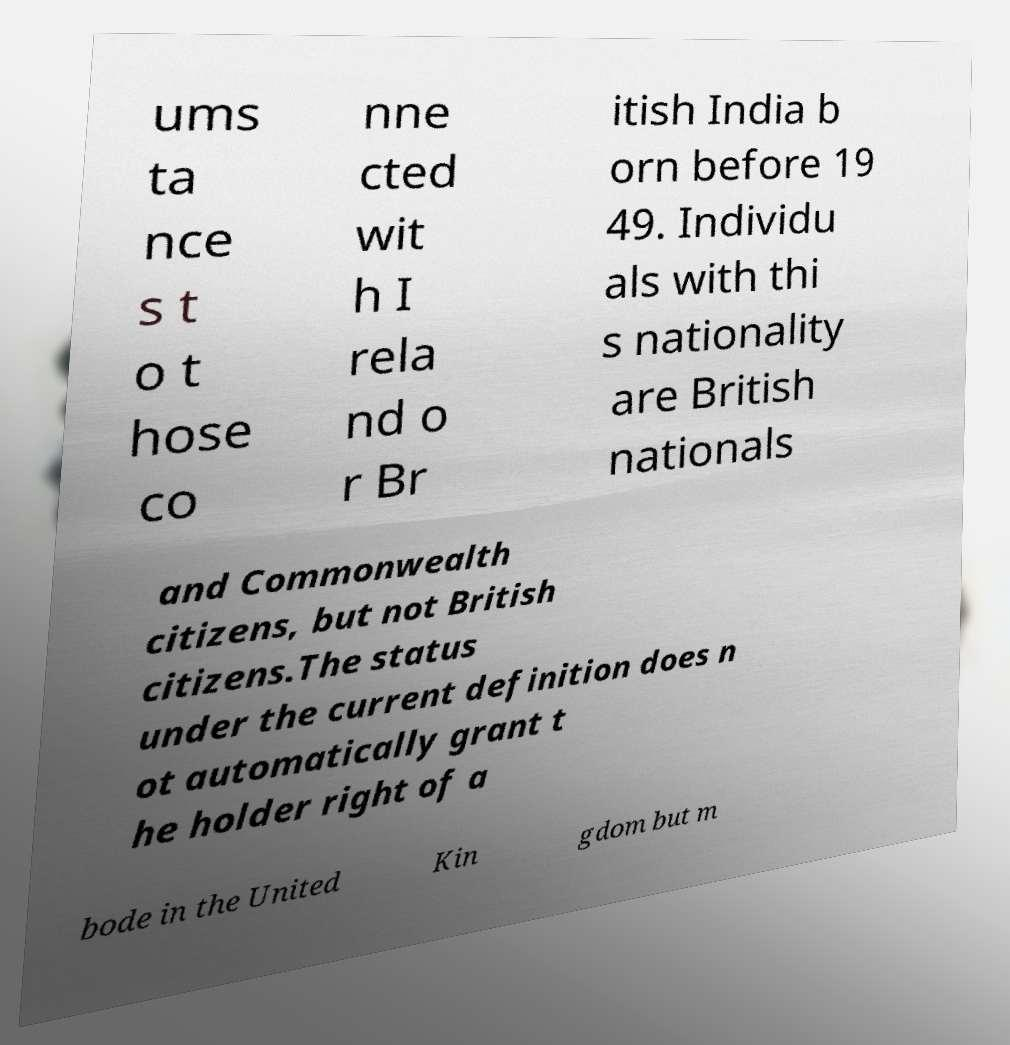Please read and relay the text visible in this image. What does it say? ums ta nce s t o t hose co nne cted wit h I rela nd o r Br itish India b orn before 19 49. Individu als with thi s nationality are British nationals and Commonwealth citizens, but not British citizens.The status under the current definition does n ot automatically grant t he holder right of a bode in the United Kin gdom but m 